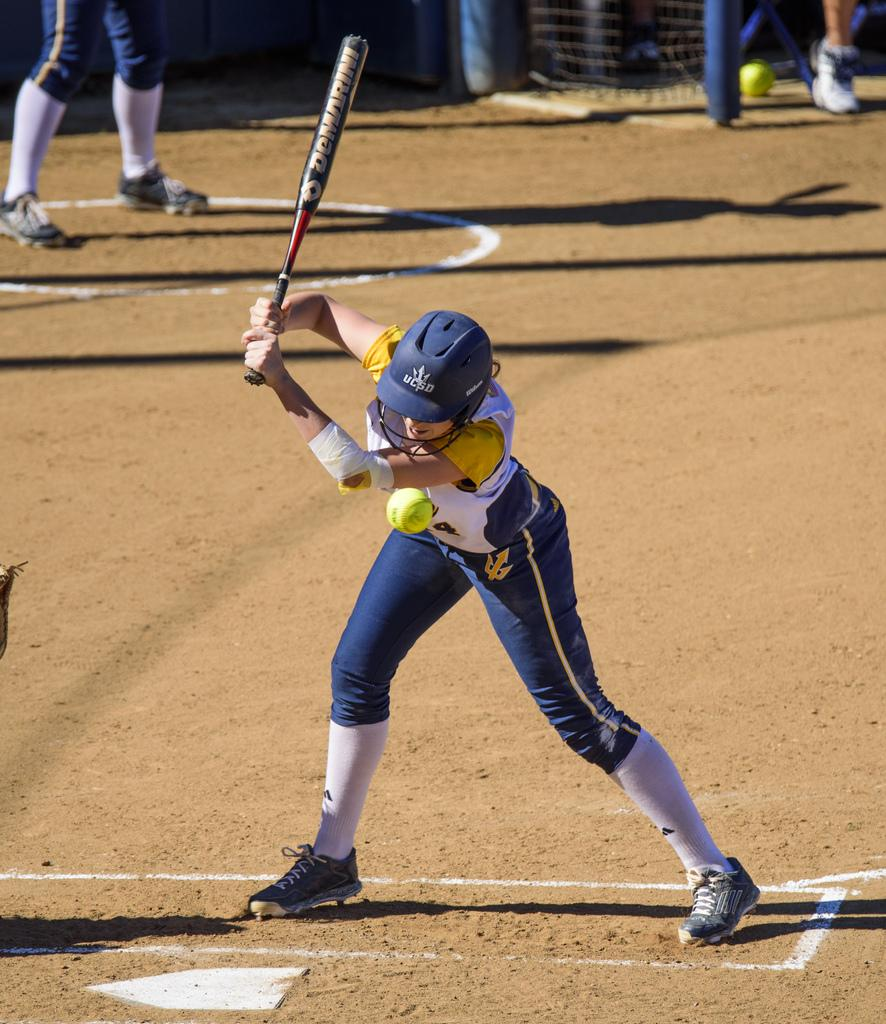What is the person in the image doing? The person is standing in the image and holding a soccer bat. What protective gear is the person wearing? The person is wearing a helmet. Can you describe the people in the background of the image? There are people in the background of the image, but their specific actions or appearances are not mentioned in the facts. What type of location is visible in the background? The background is a playground. What type of ticket can be seen in the person's hand in the image? There is no ticket present in the person's hand or anywhere else in the image. 